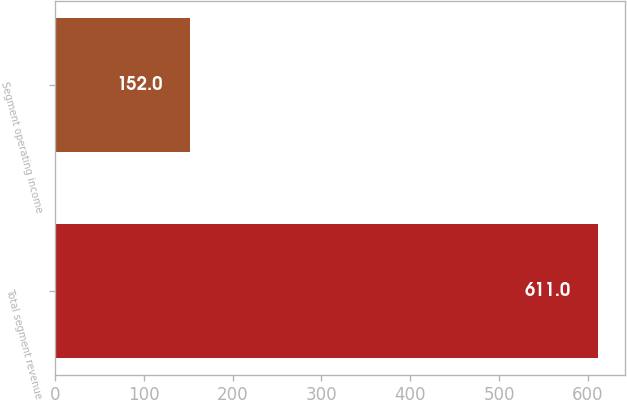<chart> <loc_0><loc_0><loc_500><loc_500><bar_chart><fcel>Total segment revenue<fcel>Segment operating income<nl><fcel>611<fcel>152<nl></chart> 